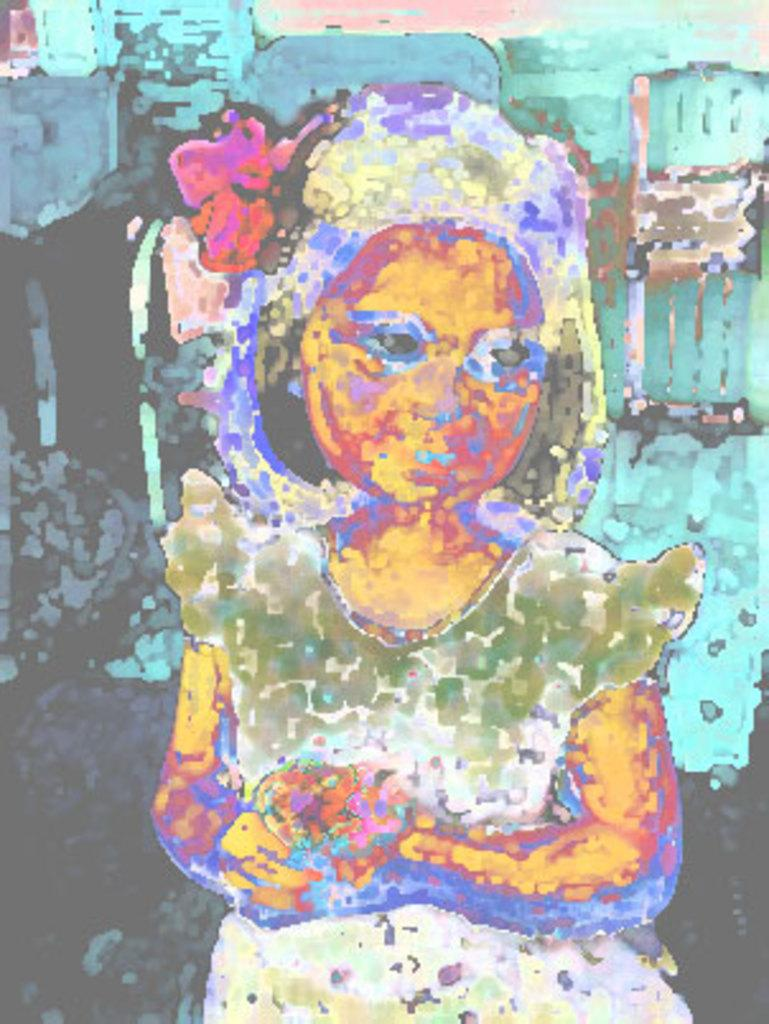What is the main subject of the image? The main subject of the image is a photograph of a girl. What is the girl doing in the image? The girl is standing in the image. Has the image been altered in any way? Yes, the image has been edited with some effect. What type of amusement can be seen in the background of the image? There is no amusement or background visible in the image; it is a photograph of a girl standing. What color is the girl's nose in the image? The color of the girl's nose cannot be determined from the image, as it is a photograph and not a detailed illustration. 